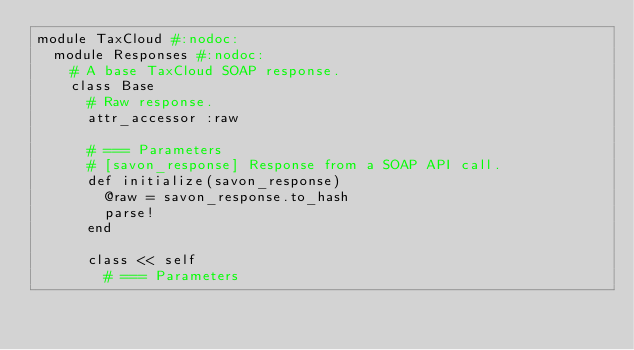Convert code to text. <code><loc_0><loc_0><loc_500><loc_500><_Ruby_>module TaxCloud #:nodoc:
  module Responses #:nodoc:
    # A base TaxCloud SOAP response.
    class Base
      # Raw response.
      attr_accessor :raw

      # === Parameters
      # [savon_response] Response from a SOAP API call.
      def initialize(savon_response)
        @raw = savon_response.to_hash
        parse!
      end

      class << self
        # === Parameters</code> 